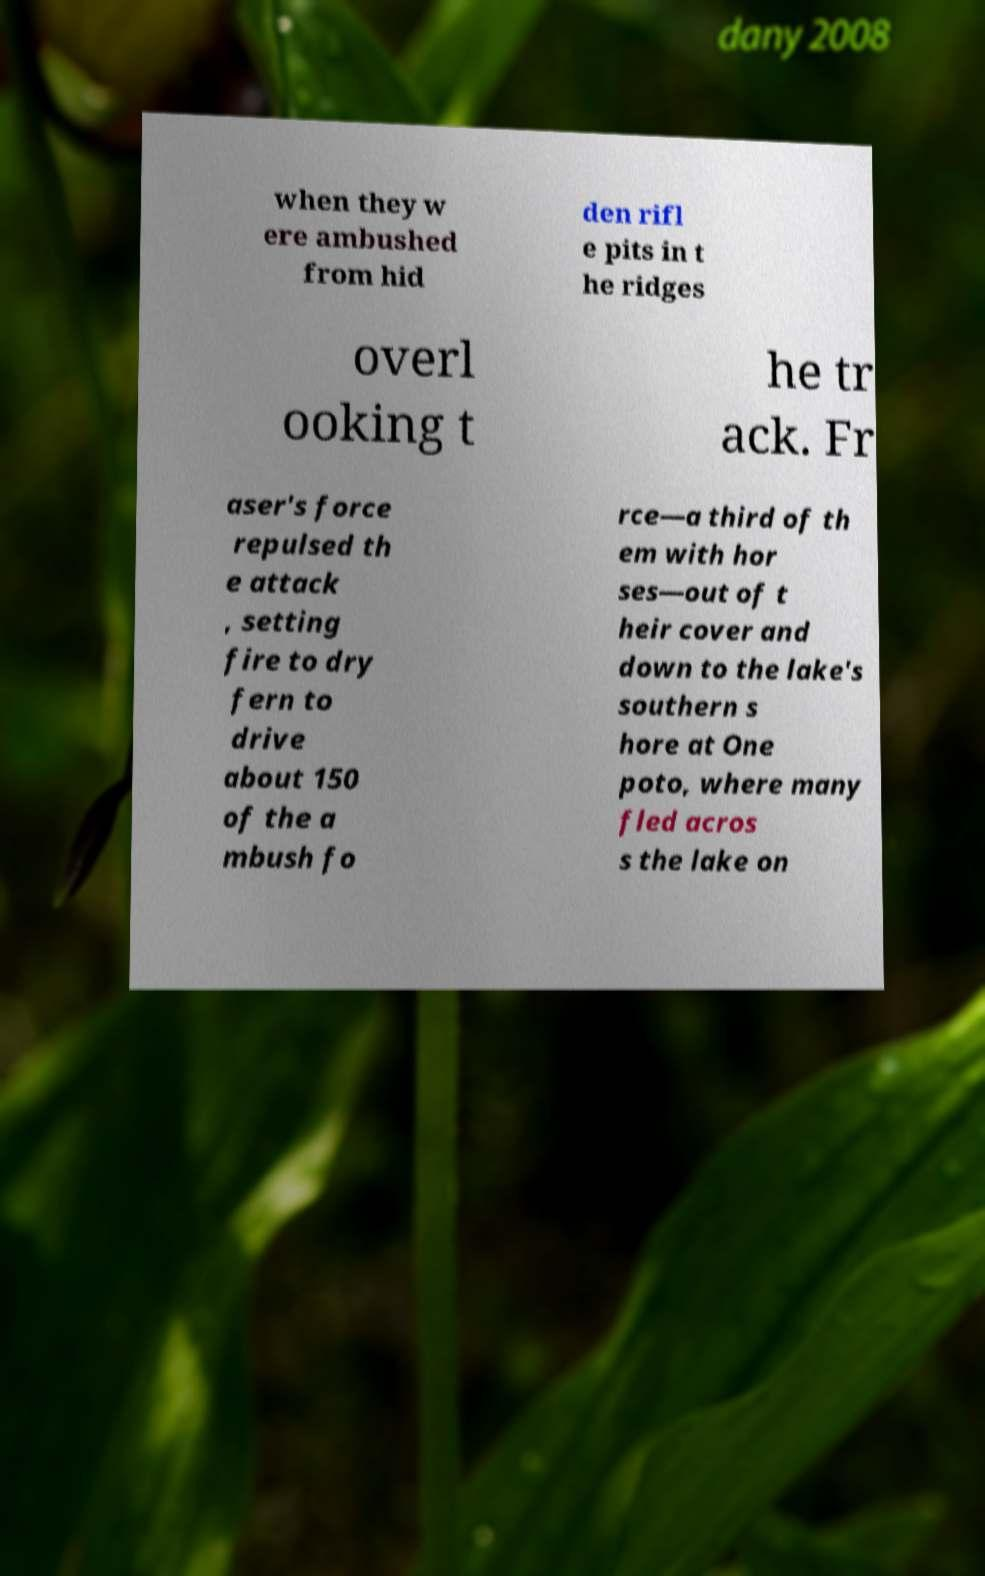Could you assist in decoding the text presented in this image and type it out clearly? when they w ere ambushed from hid den rifl e pits in t he ridges overl ooking t he tr ack. Fr aser's force repulsed th e attack , setting fire to dry fern to drive about 150 of the a mbush fo rce—a third of th em with hor ses—out of t heir cover and down to the lake's southern s hore at One poto, where many fled acros s the lake on 